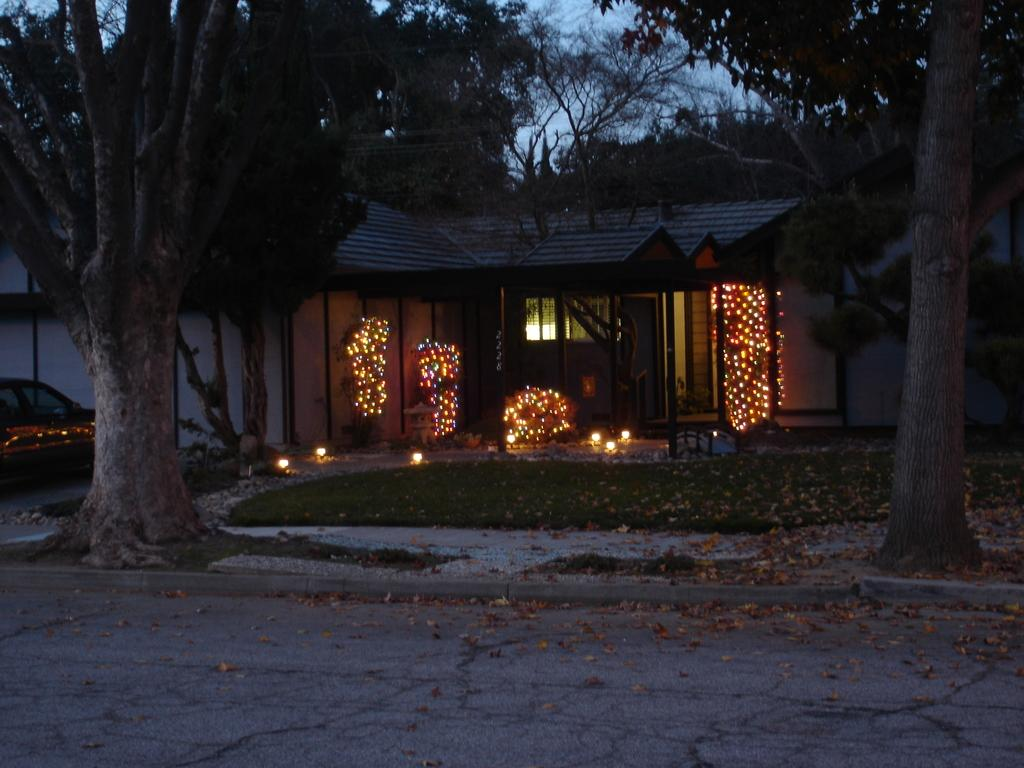What is the main subject of the image? There is a vehicle in the image. What can be seen near the house in the image? There are lights in front of the house. What type of vegetation is present in the image? There are trees and grass in the image. What else can be found in the image? There are leaves and a road in the image. What is visible in the background of the image? The sky is visible in the image. How many tomatoes are hanging from the trees in the image? There are no tomatoes present in the image; it features trees with leaves. What type of parent is shown interacting with the vehicle in the image? There is no parent present in the image; it only features a vehicle and its surroundings. 